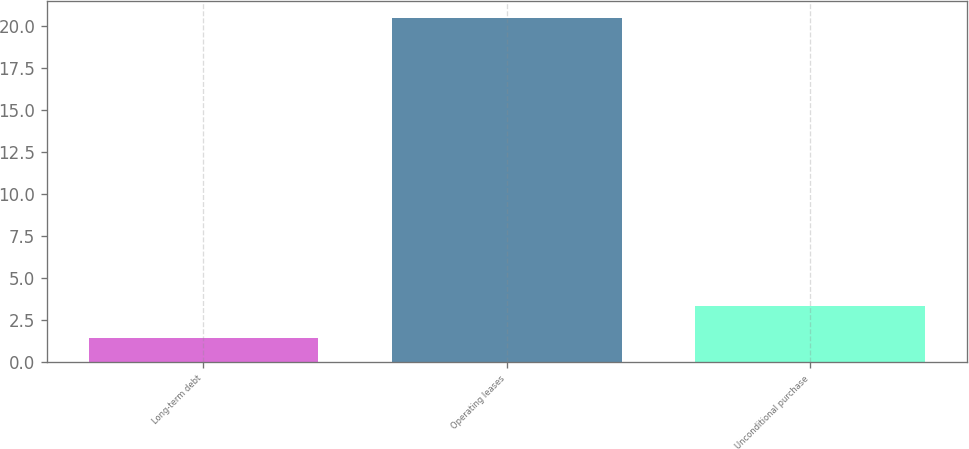<chart> <loc_0><loc_0><loc_500><loc_500><bar_chart><fcel>Long-term debt<fcel>Operating leases<fcel>Unconditional purchase<nl><fcel>1.45<fcel>20.5<fcel>3.36<nl></chart> 